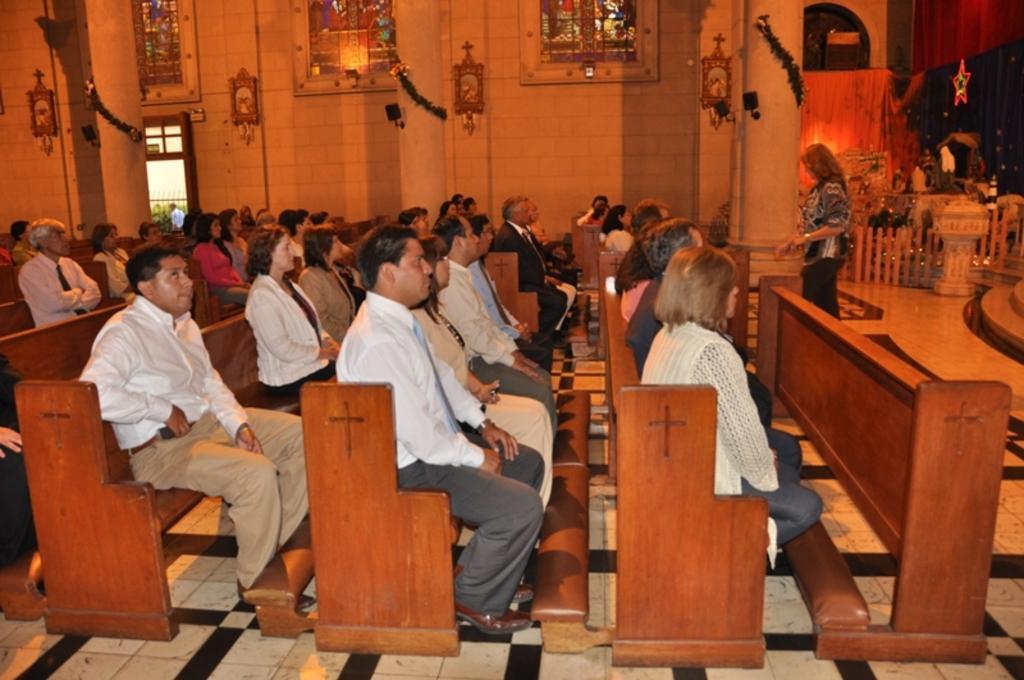Describe this image in one or two sentences. In this picture we can see people sitting in a church and praying. 